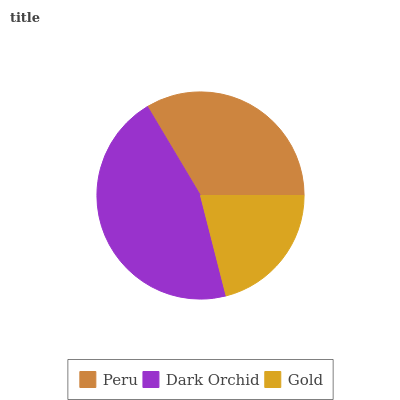Is Gold the minimum?
Answer yes or no. Yes. Is Dark Orchid the maximum?
Answer yes or no. Yes. Is Dark Orchid the minimum?
Answer yes or no. No. Is Gold the maximum?
Answer yes or no. No. Is Dark Orchid greater than Gold?
Answer yes or no. Yes. Is Gold less than Dark Orchid?
Answer yes or no. Yes. Is Gold greater than Dark Orchid?
Answer yes or no. No. Is Dark Orchid less than Gold?
Answer yes or no. No. Is Peru the high median?
Answer yes or no. Yes. Is Peru the low median?
Answer yes or no. Yes. Is Gold the high median?
Answer yes or no. No. Is Dark Orchid the low median?
Answer yes or no. No. 